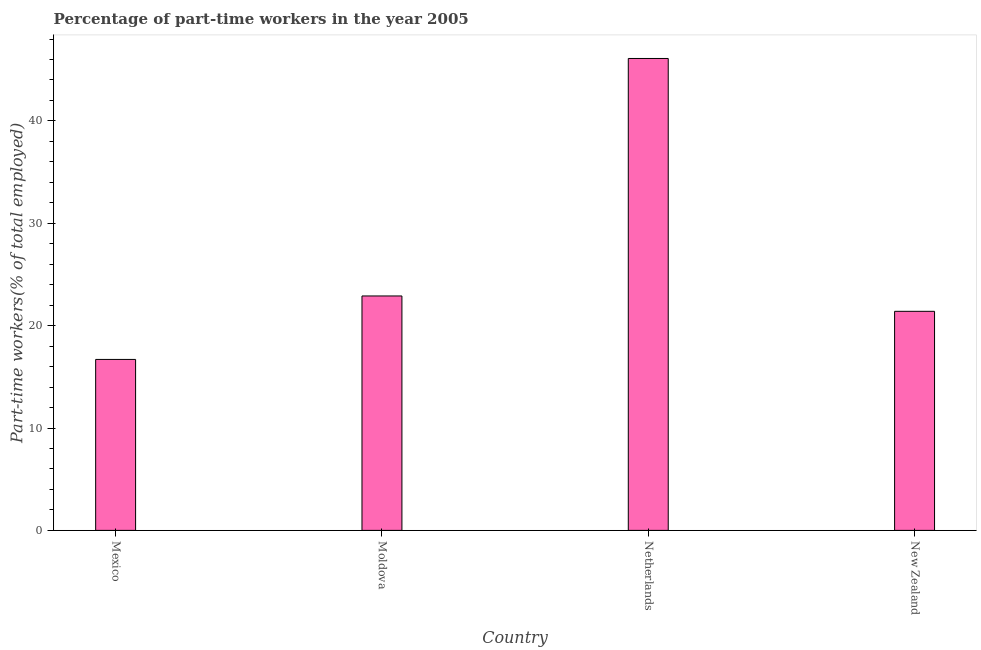Does the graph contain any zero values?
Provide a succinct answer. No. Does the graph contain grids?
Your answer should be very brief. No. What is the title of the graph?
Provide a succinct answer. Percentage of part-time workers in the year 2005. What is the label or title of the X-axis?
Your answer should be compact. Country. What is the label or title of the Y-axis?
Keep it short and to the point. Part-time workers(% of total employed). What is the percentage of part-time workers in Mexico?
Provide a short and direct response. 16.7. Across all countries, what is the maximum percentage of part-time workers?
Keep it short and to the point. 46.1. Across all countries, what is the minimum percentage of part-time workers?
Offer a very short reply. 16.7. In which country was the percentage of part-time workers minimum?
Your answer should be very brief. Mexico. What is the sum of the percentage of part-time workers?
Your answer should be compact. 107.1. What is the average percentage of part-time workers per country?
Ensure brevity in your answer.  26.77. What is the median percentage of part-time workers?
Provide a short and direct response. 22.15. In how many countries, is the percentage of part-time workers greater than 38 %?
Keep it short and to the point. 1. What is the ratio of the percentage of part-time workers in Mexico to that in Netherlands?
Offer a very short reply. 0.36. Is the difference between the percentage of part-time workers in Netherlands and New Zealand greater than the difference between any two countries?
Provide a succinct answer. No. What is the difference between the highest and the second highest percentage of part-time workers?
Your answer should be compact. 23.2. What is the difference between the highest and the lowest percentage of part-time workers?
Your response must be concise. 29.4. In how many countries, is the percentage of part-time workers greater than the average percentage of part-time workers taken over all countries?
Keep it short and to the point. 1. How many countries are there in the graph?
Provide a short and direct response. 4. What is the Part-time workers(% of total employed) of Mexico?
Give a very brief answer. 16.7. What is the Part-time workers(% of total employed) of Moldova?
Your answer should be very brief. 22.9. What is the Part-time workers(% of total employed) in Netherlands?
Your answer should be compact. 46.1. What is the Part-time workers(% of total employed) of New Zealand?
Your answer should be compact. 21.4. What is the difference between the Part-time workers(% of total employed) in Mexico and Netherlands?
Offer a terse response. -29.4. What is the difference between the Part-time workers(% of total employed) in Mexico and New Zealand?
Provide a succinct answer. -4.7. What is the difference between the Part-time workers(% of total employed) in Moldova and Netherlands?
Offer a terse response. -23.2. What is the difference between the Part-time workers(% of total employed) in Moldova and New Zealand?
Offer a very short reply. 1.5. What is the difference between the Part-time workers(% of total employed) in Netherlands and New Zealand?
Your answer should be compact. 24.7. What is the ratio of the Part-time workers(% of total employed) in Mexico to that in Moldova?
Your response must be concise. 0.73. What is the ratio of the Part-time workers(% of total employed) in Mexico to that in Netherlands?
Your response must be concise. 0.36. What is the ratio of the Part-time workers(% of total employed) in Mexico to that in New Zealand?
Ensure brevity in your answer.  0.78. What is the ratio of the Part-time workers(% of total employed) in Moldova to that in Netherlands?
Your answer should be compact. 0.5. What is the ratio of the Part-time workers(% of total employed) in Moldova to that in New Zealand?
Your response must be concise. 1.07. What is the ratio of the Part-time workers(% of total employed) in Netherlands to that in New Zealand?
Offer a very short reply. 2.15. 